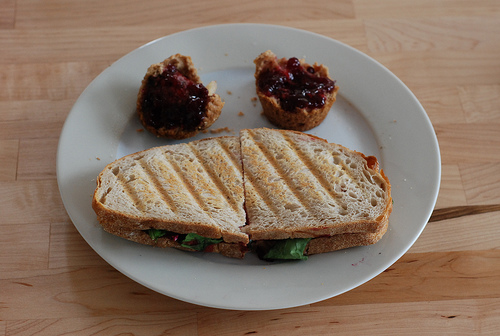Could you estimate the time of day this meal is typically eaten? Based on the composition of the meal, which includes a sandwich and English muffins with jam, it seems like a type of food that might commonly be eaten during lunch or possibly as a brunch. 